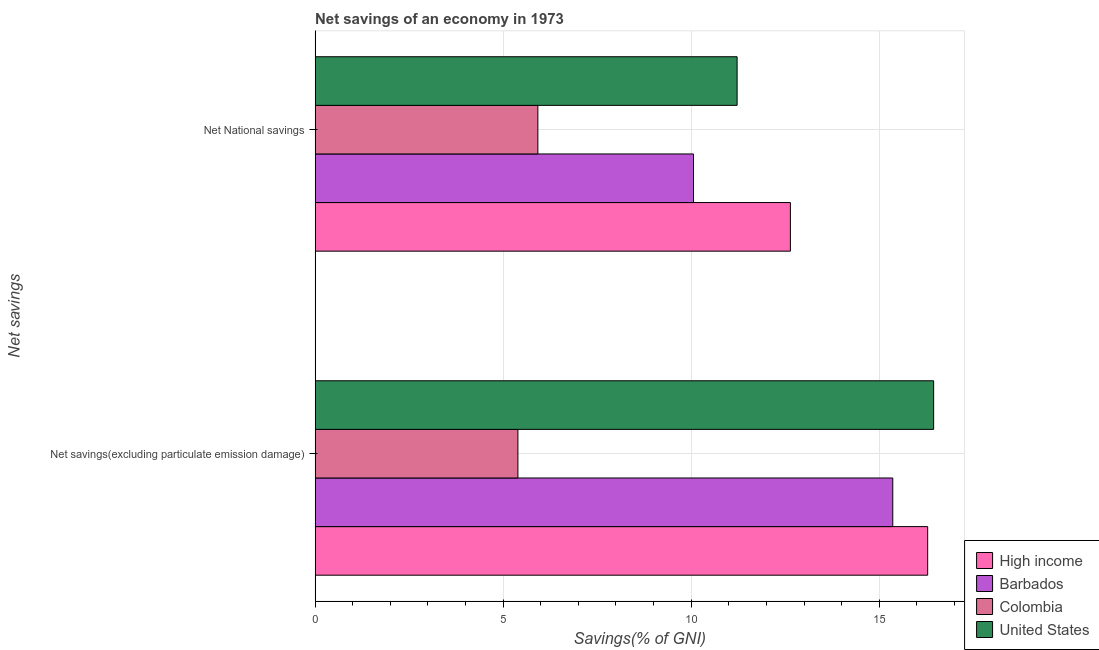How many different coloured bars are there?
Offer a very short reply. 4. How many groups of bars are there?
Provide a succinct answer. 2. Are the number of bars on each tick of the Y-axis equal?
Ensure brevity in your answer.  Yes. How many bars are there on the 1st tick from the bottom?
Offer a very short reply. 4. What is the label of the 1st group of bars from the top?
Make the answer very short. Net National savings. What is the net national savings in High income?
Make the answer very short. 12.64. Across all countries, what is the maximum net savings(excluding particulate emission damage)?
Provide a short and direct response. 16.45. Across all countries, what is the minimum net national savings?
Provide a succinct answer. 5.92. In which country was the net national savings minimum?
Keep it short and to the point. Colombia. What is the total net savings(excluding particulate emission damage) in the graph?
Offer a terse response. 53.49. What is the difference between the net savings(excluding particulate emission damage) in High income and that in United States?
Your answer should be very brief. -0.16. What is the difference between the net national savings in High income and the net savings(excluding particulate emission damage) in Barbados?
Your answer should be very brief. -2.72. What is the average net national savings per country?
Your response must be concise. 9.96. What is the difference between the net national savings and net savings(excluding particulate emission damage) in Colombia?
Your response must be concise. 0.53. In how many countries, is the net national savings greater than 4 %?
Provide a short and direct response. 4. What is the ratio of the net savings(excluding particulate emission damage) in High income to that in Barbados?
Keep it short and to the point. 1.06. Is the net national savings in United States less than that in Colombia?
Offer a terse response. No. In how many countries, is the net national savings greater than the average net national savings taken over all countries?
Make the answer very short. 3. Are all the bars in the graph horizontal?
Give a very brief answer. Yes. Does the graph contain any zero values?
Offer a very short reply. No. Does the graph contain grids?
Your answer should be compact. Yes. What is the title of the graph?
Keep it short and to the point. Net savings of an economy in 1973. What is the label or title of the X-axis?
Provide a short and direct response. Savings(% of GNI). What is the label or title of the Y-axis?
Your response must be concise. Net savings. What is the Savings(% of GNI) in High income in Net savings(excluding particulate emission damage)?
Give a very brief answer. 16.29. What is the Savings(% of GNI) in Barbados in Net savings(excluding particulate emission damage)?
Keep it short and to the point. 15.36. What is the Savings(% of GNI) of Colombia in Net savings(excluding particulate emission damage)?
Provide a succinct answer. 5.39. What is the Savings(% of GNI) in United States in Net savings(excluding particulate emission damage)?
Offer a terse response. 16.45. What is the Savings(% of GNI) in High income in Net National savings?
Your answer should be very brief. 12.64. What is the Savings(% of GNI) of Barbados in Net National savings?
Your response must be concise. 10.06. What is the Savings(% of GNI) in Colombia in Net National savings?
Ensure brevity in your answer.  5.92. What is the Savings(% of GNI) in United States in Net National savings?
Give a very brief answer. 11.22. Across all Net savings, what is the maximum Savings(% of GNI) of High income?
Your answer should be very brief. 16.29. Across all Net savings, what is the maximum Savings(% of GNI) of Barbados?
Ensure brevity in your answer.  15.36. Across all Net savings, what is the maximum Savings(% of GNI) of Colombia?
Your answer should be compact. 5.92. Across all Net savings, what is the maximum Savings(% of GNI) in United States?
Offer a terse response. 16.45. Across all Net savings, what is the minimum Savings(% of GNI) in High income?
Give a very brief answer. 12.64. Across all Net savings, what is the minimum Savings(% of GNI) in Barbados?
Your answer should be compact. 10.06. Across all Net savings, what is the minimum Savings(% of GNI) in Colombia?
Provide a succinct answer. 5.39. Across all Net savings, what is the minimum Savings(% of GNI) in United States?
Ensure brevity in your answer.  11.22. What is the total Savings(% of GNI) of High income in the graph?
Your answer should be compact. 28.93. What is the total Savings(% of GNI) of Barbados in the graph?
Your answer should be compact. 25.42. What is the total Savings(% of GNI) in Colombia in the graph?
Your answer should be compact. 11.32. What is the total Savings(% of GNI) in United States in the graph?
Your answer should be very brief. 27.67. What is the difference between the Savings(% of GNI) of High income in Net savings(excluding particulate emission damage) and that in Net National savings?
Keep it short and to the point. 3.65. What is the difference between the Savings(% of GNI) of Barbados in Net savings(excluding particulate emission damage) and that in Net National savings?
Keep it short and to the point. 5.3. What is the difference between the Savings(% of GNI) in Colombia in Net savings(excluding particulate emission damage) and that in Net National savings?
Your answer should be compact. -0.53. What is the difference between the Savings(% of GNI) in United States in Net savings(excluding particulate emission damage) and that in Net National savings?
Keep it short and to the point. 5.23. What is the difference between the Savings(% of GNI) of High income in Net savings(excluding particulate emission damage) and the Savings(% of GNI) of Barbados in Net National savings?
Keep it short and to the point. 6.23. What is the difference between the Savings(% of GNI) in High income in Net savings(excluding particulate emission damage) and the Savings(% of GNI) in Colombia in Net National savings?
Ensure brevity in your answer.  10.37. What is the difference between the Savings(% of GNI) in High income in Net savings(excluding particulate emission damage) and the Savings(% of GNI) in United States in Net National savings?
Provide a succinct answer. 5.07. What is the difference between the Savings(% of GNI) in Barbados in Net savings(excluding particulate emission damage) and the Savings(% of GNI) in Colombia in Net National savings?
Give a very brief answer. 9.44. What is the difference between the Savings(% of GNI) of Barbados in Net savings(excluding particulate emission damage) and the Savings(% of GNI) of United States in Net National savings?
Offer a terse response. 4.14. What is the difference between the Savings(% of GNI) of Colombia in Net savings(excluding particulate emission damage) and the Savings(% of GNI) of United States in Net National savings?
Your answer should be compact. -5.83. What is the average Savings(% of GNI) of High income per Net savings?
Offer a very short reply. 14.46. What is the average Savings(% of GNI) in Barbados per Net savings?
Give a very brief answer. 12.71. What is the average Savings(% of GNI) in Colombia per Net savings?
Offer a very short reply. 5.66. What is the average Savings(% of GNI) of United States per Net savings?
Make the answer very short. 13.83. What is the difference between the Savings(% of GNI) in High income and Savings(% of GNI) in Barbados in Net savings(excluding particulate emission damage)?
Provide a succinct answer. 0.93. What is the difference between the Savings(% of GNI) of High income and Savings(% of GNI) of Colombia in Net savings(excluding particulate emission damage)?
Your response must be concise. 10.9. What is the difference between the Savings(% of GNI) of High income and Savings(% of GNI) of United States in Net savings(excluding particulate emission damage)?
Make the answer very short. -0.16. What is the difference between the Savings(% of GNI) in Barbados and Savings(% of GNI) in Colombia in Net savings(excluding particulate emission damage)?
Your response must be concise. 9.97. What is the difference between the Savings(% of GNI) of Barbados and Savings(% of GNI) of United States in Net savings(excluding particulate emission damage)?
Provide a succinct answer. -1.09. What is the difference between the Savings(% of GNI) in Colombia and Savings(% of GNI) in United States in Net savings(excluding particulate emission damage)?
Make the answer very short. -11.05. What is the difference between the Savings(% of GNI) of High income and Savings(% of GNI) of Barbados in Net National savings?
Make the answer very short. 2.58. What is the difference between the Savings(% of GNI) of High income and Savings(% of GNI) of Colombia in Net National savings?
Ensure brevity in your answer.  6.71. What is the difference between the Savings(% of GNI) in High income and Savings(% of GNI) in United States in Net National savings?
Keep it short and to the point. 1.42. What is the difference between the Savings(% of GNI) in Barbados and Savings(% of GNI) in Colombia in Net National savings?
Give a very brief answer. 4.14. What is the difference between the Savings(% of GNI) of Barbados and Savings(% of GNI) of United States in Net National savings?
Provide a short and direct response. -1.16. What is the difference between the Savings(% of GNI) in Colombia and Savings(% of GNI) in United States in Net National savings?
Offer a very short reply. -5.3. What is the ratio of the Savings(% of GNI) of High income in Net savings(excluding particulate emission damage) to that in Net National savings?
Your answer should be compact. 1.29. What is the ratio of the Savings(% of GNI) in Barbados in Net savings(excluding particulate emission damage) to that in Net National savings?
Offer a terse response. 1.53. What is the ratio of the Savings(% of GNI) of Colombia in Net savings(excluding particulate emission damage) to that in Net National savings?
Keep it short and to the point. 0.91. What is the ratio of the Savings(% of GNI) of United States in Net savings(excluding particulate emission damage) to that in Net National savings?
Provide a succinct answer. 1.47. What is the difference between the highest and the second highest Savings(% of GNI) of High income?
Offer a very short reply. 3.65. What is the difference between the highest and the second highest Savings(% of GNI) of Barbados?
Your answer should be compact. 5.3. What is the difference between the highest and the second highest Savings(% of GNI) in Colombia?
Offer a terse response. 0.53. What is the difference between the highest and the second highest Savings(% of GNI) in United States?
Give a very brief answer. 5.23. What is the difference between the highest and the lowest Savings(% of GNI) in High income?
Provide a short and direct response. 3.65. What is the difference between the highest and the lowest Savings(% of GNI) of Barbados?
Offer a very short reply. 5.3. What is the difference between the highest and the lowest Savings(% of GNI) of Colombia?
Make the answer very short. 0.53. What is the difference between the highest and the lowest Savings(% of GNI) in United States?
Your answer should be compact. 5.23. 